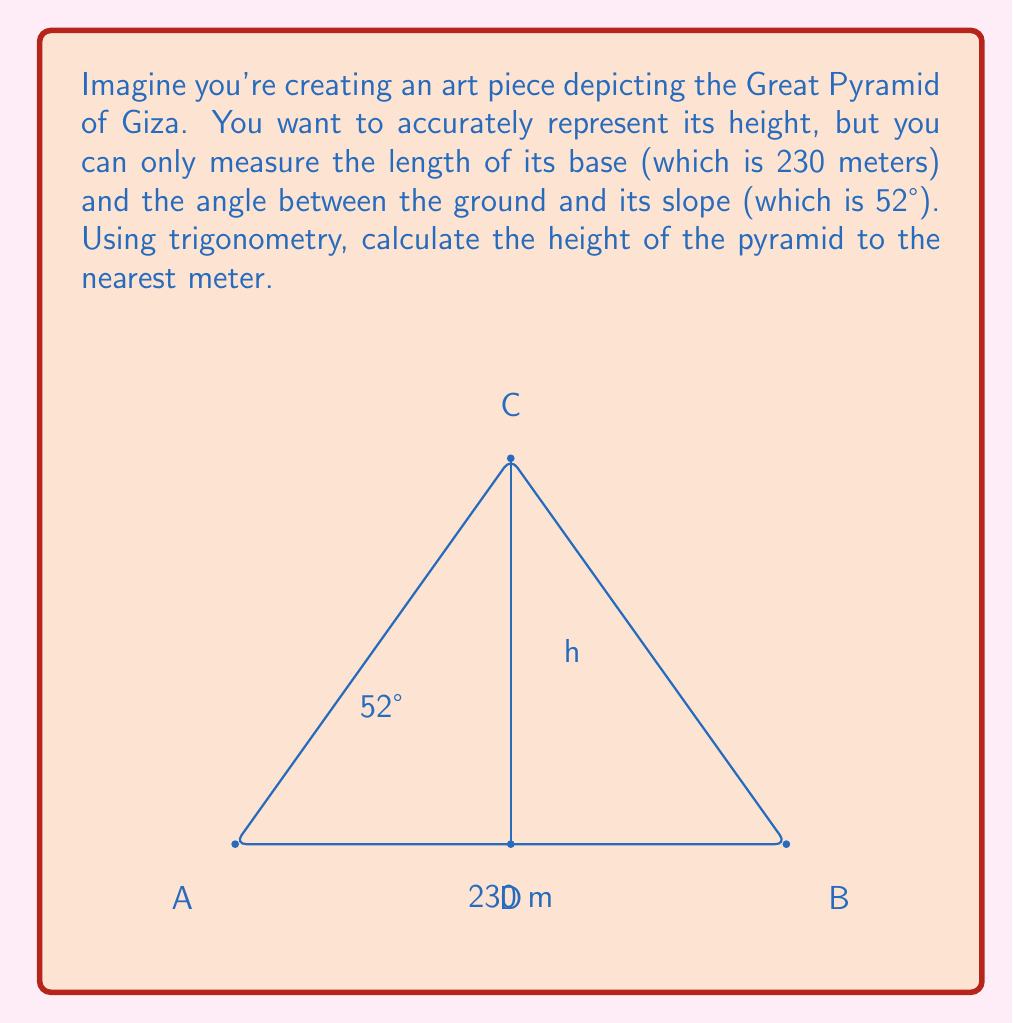Give your solution to this math problem. Let's approach this step-by-step:

1) In this problem, we have a right triangle formed by half of the pyramid's base, its height, and its slope.

2) We know:
   - Half of the base length = 230 m ÷ 2 = 115 m
   - The angle between the ground and the slope = 52°

3) We need to find the height. This forms the opposite side to the known angle in our right triangle.

4) The trigonometric ratio that relates the opposite side to the adjacent side in a right triangle is the tangent (tan).

5) We can set up the equation:
   
   $$ \tan(52°) = \frac{\text{opposite}}{\text{adjacent}} = \frac{\text{height}}{115} $$

6) Rearranging this equation to solve for height:
   
   $$ \text{height} = 115 \times \tan(52°) $$

7) Using a calculator (or trigonometric tables):
   
   $$ \text{height} = 115 \times 1.2799 \approx 147.19 \text{ meters} $$

8) Rounding to the nearest meter as requested:

   $$ \text{height} \approx 147 \text{ meters} $$
Answer: 147 meters 